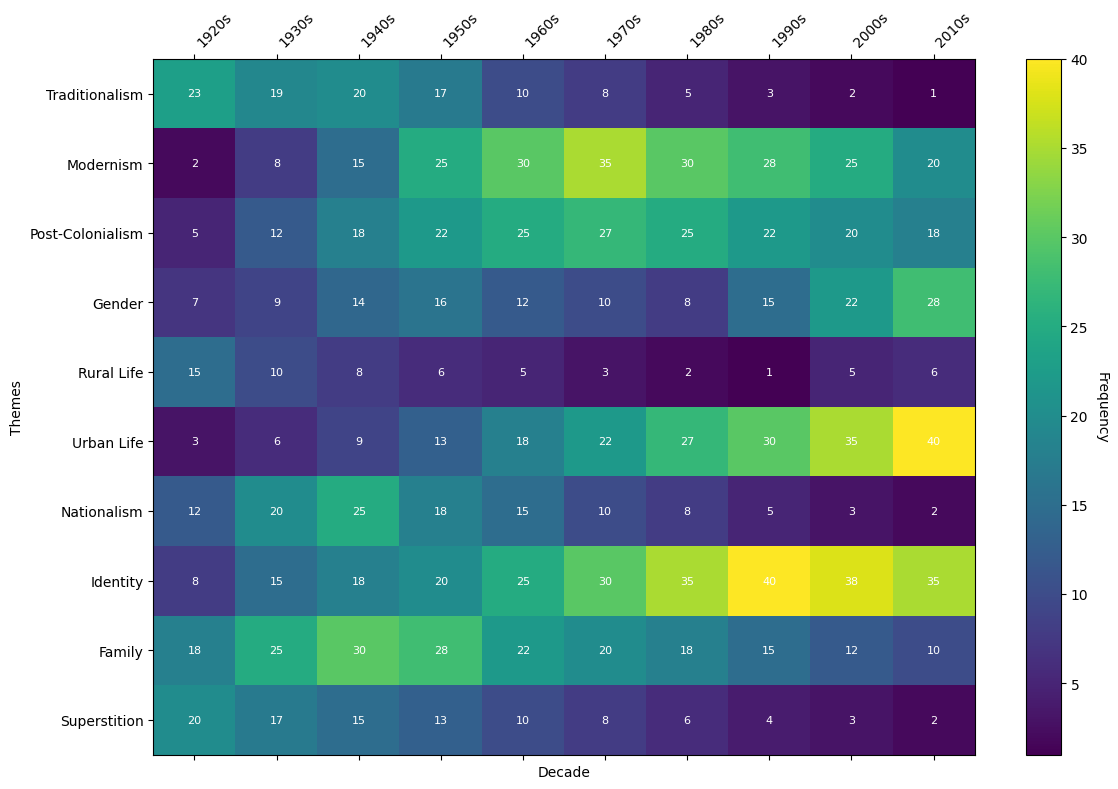Which decade had the highest frequency of the theme 'Modernism'? To find the decade with the highest frequency of 'Modernism', look for the darkest color block in the 'Modernism' row. This corresponds to the 1970s with a frequency of 35.
Answer: 1970s Which theme had the lowest frequency in the 1990s? Locate the 1990s column and identify the lightest color block. The theme 'Rural Life' has the lowest frequency with 1.
Answer: Rural Life Compare the frequency of 'Nationalism' and 'Urban Life' in the 1940s. Which one is higher and by how much? In the 1940s column, 'Nationalism' has a frequency of 25 and 'Urban Life' has a frequency of 9. The difference is 25 - 9 = 16, with 'Nationalism' being higher.
Answer: Nationalism by 16 What is the average frequency of the theme 'Family' across all decades? Add the frequencies of 'Family' across all decades: 18 + 25 + 30 + 28 + 22 + 20 + 18 + 15 + 12 + 10 = 198. Divide by the number of decades (10). So the average is 198 / 10 = 19.8.
Answer: 19.8 During which decade did both 'Traditionalism' and 'Superstition' themes see their minimum frequency? Check each decade and find where both 'Traditionalism' and 'Superstition' have their lowest values. The 2010s have the lowest values with frequencies of 1 and 2, respectively.
Answer: 2010s How does the frequency of 'Identity' in the 1980s compare to its frequency in the 2000s? 'Identity' has a frequency of 35 in the 1980s and 38 in the 2000s. The frequency increased by 38 - 35 = 3.
Answer: Increased by 3 What is the sum of the frequencies of 'Post-Colonialism' and 'Gender' themes in the 1970s? 'Post-Colonialism' has a frequency of 27 and 'Gender' has a frequency of 10 in the 1970s. Summing them gives 27 + 10 = 37.
Answer: 37 Identify the decade with the lowest frequency of the 'Traditionalism' theme and provide the value. Review the 'Traditionalism' row and find the lowest value. The 2010s have the lowest frequency with a value of 1.
Answer: 2010s with 1 Which theme showed consistent frequency increase from the 1920s to the 2010s? Check each row for a consistent increase from 1920s to 2010s. The theme 'Urban Life' shows a consistent increase from 3 to 40.
Answer: Urban Life 